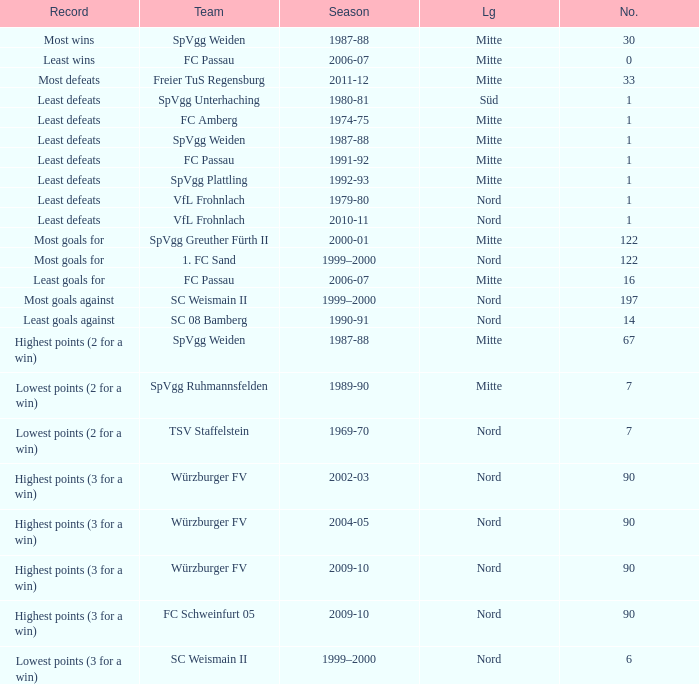What league has a number less than 1? Mitte. 